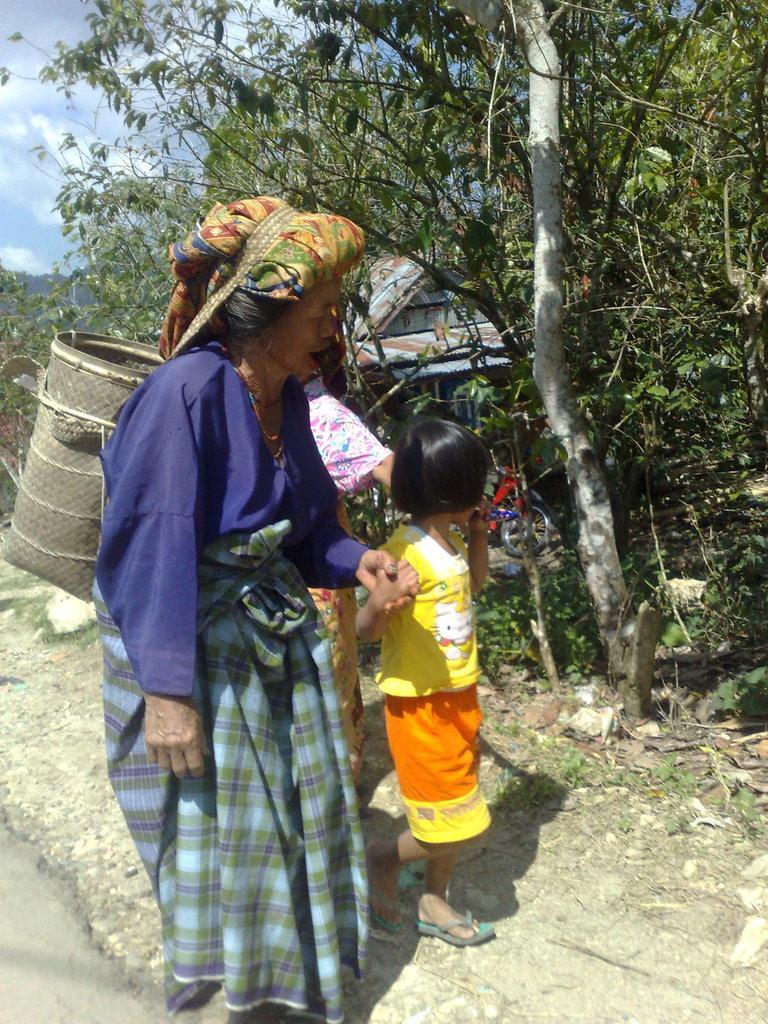Could you give a brief overview of what you see in this image? In this picture we can see a old women wearing blue dress with wooden basket on the back, Holding a small girl hand and walking on the road side. In the background there are some trees. 